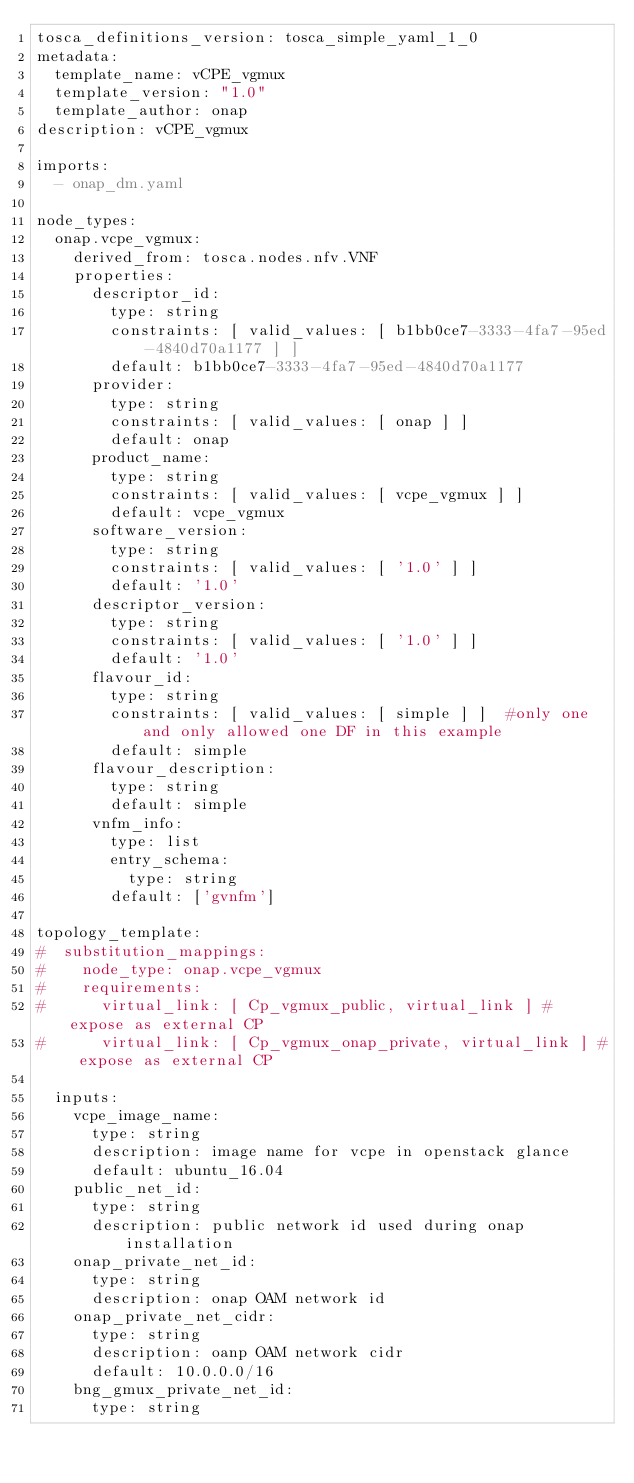<code> <loc_0><loc_0><loc_500><loc_500><_YAML_>tosca_definitions_version: tosca_simple_yaml_1_0
metadata:
  template_name: vCPE_vgmux
  template_version: "1.0"
  template_author: onap
description: vCPE_vgmux

imports:
  - onap_dm.yaml

node_types:
  onap.vcpe_vgmux:
    derived_from: tosca.nodes.nfv.VNF
    properties:
      descriptor_id:
        type: string
        constraints: [ valid_values: [ b1bb0ce7-3333-4fa7-95ed-4840d70a1177 ] ]
        default: b1bb0ce7-3333-4fa7-95ed-4840d70a1177
      provider:
        type: string
        constraints: [ valid_values: [ onap ] ]
        default: onap
      product_name:
        type: string
        constraints: [ valid_values: [ vcpe_vgmux ] ]
        default: vcpe_vgmux
      software_version:
        type: string
        constraints: [ valid_values: [ '1.0' ] ]
        default: '1.0'
      descriptor_version:
        type: string
        constraints: [ valid_values: [ '1.0' ] ]
        default: '1.0'
      flavour_id:
        type: string
        constraints: [ valid_values: [ simple ] ]  #only one and only allowed one DF in this example
        default: simple
      flavour_description:
        type: string
        default: simple
      vnfm_info:
        type: list
        entry_schema:
          type: string
        default: ['gvnfm']

topology_template:
#  substitution_mappings:
#    node_type: onap.vcpe_vgmux
#    requirements:
#      virtual_link: [ Cp_vgmux_public, virtual_link ] # expose as external CP
#      virtual_link: [ Cp_vgmux_onap_private, virtual_link ] # expose as external CP

  inputs:
    vcpe_image_name:
      type: string
      description: image name for vcpe in openstack glance
      default: ubuntu_16.04
    public_net_id:
      type: string
      description: public network id used during onap installation
    onap_private_net_id:
      type: string
      description: onap OAM network id
    onap_private_net_cidr:
      type: string
      description: oanp OAM network cidr
      default: 10.0.0.0/16
    bng_gmux_private_net_id:
      type: string</code> 